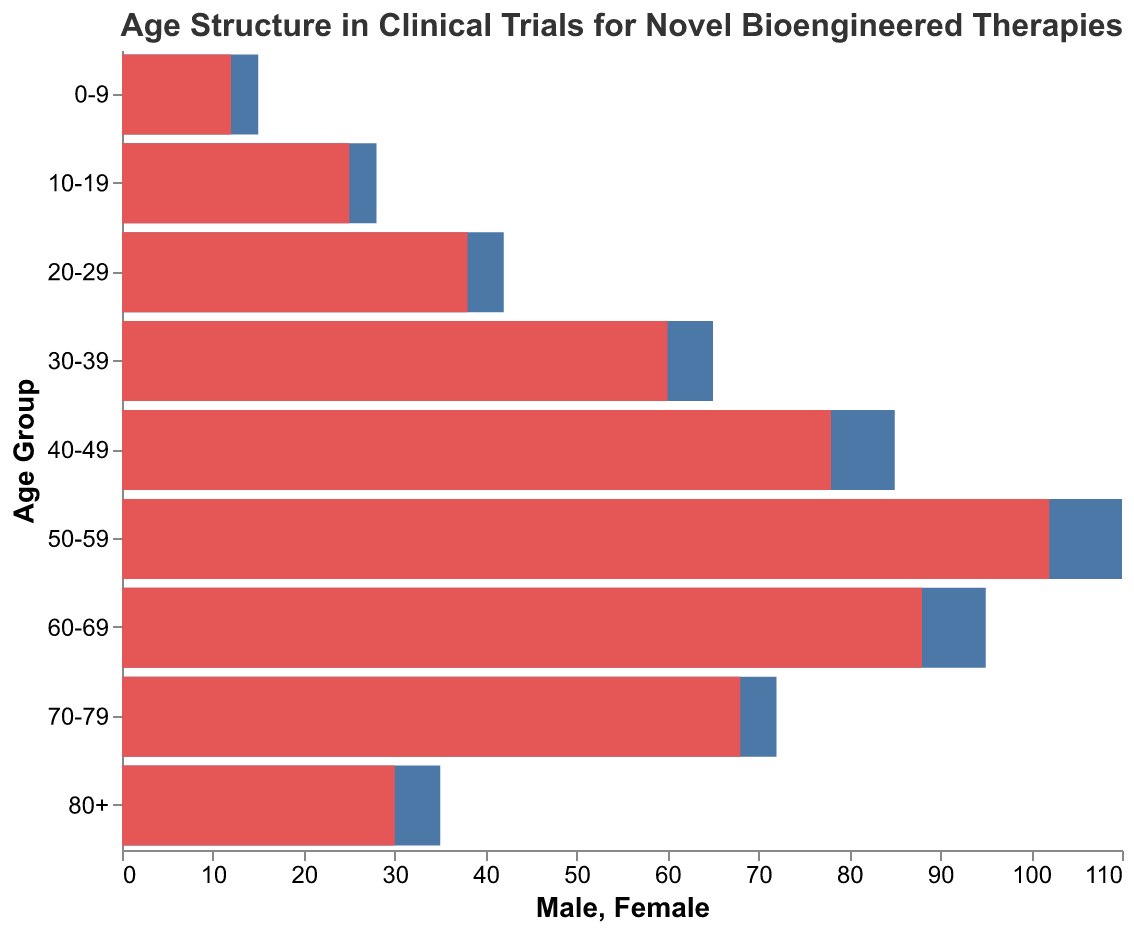What age group has the highest number of males participating in the cardiovascular diseases category? The figure shows the age structure of participants in different disease categories. For cardiovascular diseases, males in the 50-59 age group have the highest value with a magnitude of 110.
Answer: 50-59 What is the total number of females in the cancer category? Sum the number of females in the respective age groups for the cancer category: 20-29 (38) and 30-39 (60). The total is 38 + 60 = 98.
Answer: 98 Which age group has the smallest gender gap in the neurodegenerative diseases category? Look at the bars in the neurodegenerative diseases category. The 70-79 age group shows the smallest gender gap as the values are 72 for males and 68 for females, resulting in a gap of 4.
Answer: 70-79 In the category of rare genetic disorders, which gender has more participants aged 10-19 years? For rare genetic disorders, females in the 10-19 age group have a higher number with 25 compared to males with 28 (negative direction).
Answer: Female How does the number of males in the 40-49 age group compare between cardiovascular diseases and cancer? For the age group 40-49, the number of males in cardiovascular diseases is 85 and in cancer is not listed, so cardiovascular diseases have higher participants in this age group.
Answer: Higher in cardiovascular diseases What is the average number of females in the autoimmune disorders category? There's only one age group (80+) listed for autoimmune disorders with 30 females. So, the average is simply 30.
Answer: 30 Which age group has the highest female participation across all categories? Observing the figure, the age group 50-59 in cardiovascular diseases has the highest female participation with 102 individuals.
Answer: 50-59 What is the difference in the number of males between the 0-9 and 10-19 age groups in rare genetic disorders? The figure shows 15 males in the 0-9 age group and 28 in the 10-19 age group. The difference is 28 - 15 = 13.
Answer: 13 What is the total number of participants (both genders) in the neurodegenerative diseases category? Summing up both genders in neurodegenerative diseases: (95 + 88) for 60-69 and (72 + 68) for 70-79. Total = 183 + 140 = 323.
Answer: 323 